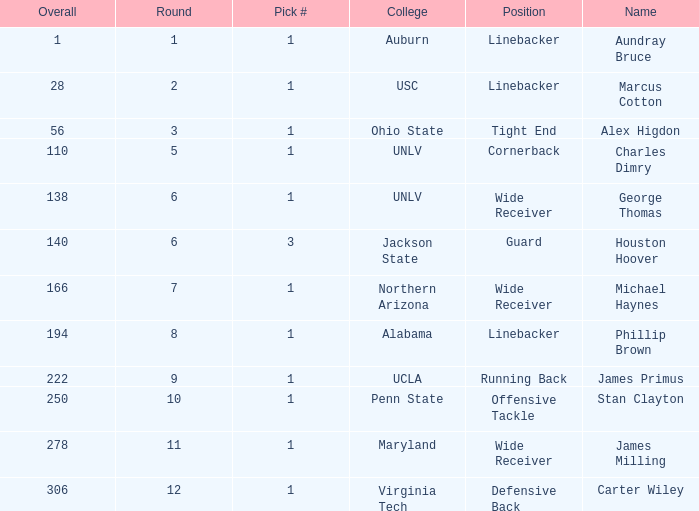What is Aundray Bruce's Pick #? 1.0. Would you mind parsing the complete table? {'header': ['Overall', 'Round', 'Pick #', 'College', 'Position', 'Name'], 'rows': [['1', '1', '1', 'Auburn', 'Linebacker', 'Aundray Bruce'], ['28', '2', '1', 'USC', 'Linebacker', 'Marcus Cotton'], ['56', '3', '1', 'Ohio State', 'Tight End', 'Alex Higdon'], ['110', '5', '1', 'UNLV', 'Cornerback', 'Charles Dimry'], ['138', '6', '1', 'UNLV', 'Wide Receiver', 'George Thomas'], ['140', '6', '3', 'Jackson State', 'Guard', 'Houston Hoover'], ['166', '7', '1', 'Northern Arizona', 'Wide Receiver', 'Michael Haynes'], ['194', '8', '1', 'Alabama', 'Linebacker', 'Phillip Brown'], ['222', '9', '1', 'UCLA', 'Running Back', 'James Primus'], ['250', '10', '1', 'Penn State', 'Offensive Tackle', 'Stan Clayton'], ['278', '11', '1', 'Maryland', 'Wide Receiver', 'James Milling'], ['306', '12', '1', 'Virginia Tech', 'Defensive Back', 'Carter Wiley']]} 